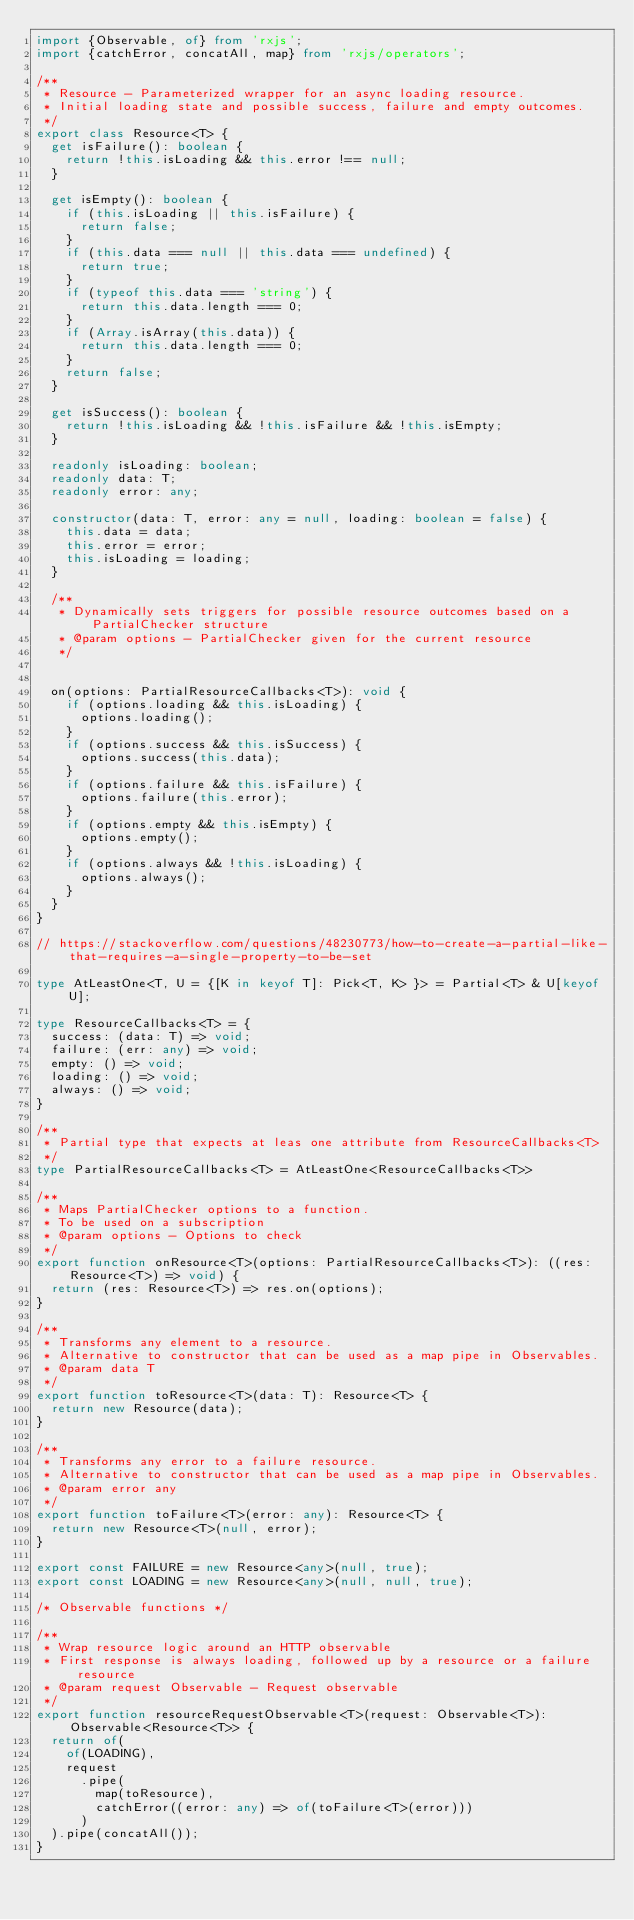Convert code to text. <code><loc_0><loc_0><loc_500><loc_500><_TypeScript_>import {Observable, of} from 'rxjs';
import {catchError, concatAll, map} from 'rxjs/operators';

/**
 * Resource - Parameterized wrapper for an async loading resource.
 * Initial loading state and possible success, failure and empty outcomes.
 */
export class Resource<T> {
  get isFailure(): boolean {
    return !this.isLoading && this.error !== null;
  }

  get isEmpty(): boolean {
    if (this.isLoading || this.isFailure) {
      return false;
    }
    if (this.data === null || this.data === undefined) {
      return true;
    }
    if (typeof this.data === 'string') {
      return this.data.length === 0;
    }
    if (Array.isArray(this.data)) {
      return this.data.length === 0;
    }
    return false;
  }

  get isSuccess(): boolean {
    return !this.isLoading && !this.isFailure && !this.isEmpty;
  }

  readonly isLoading: boolean;
  readonly data: T;
  readonly error: any;

  constructor(data: T, error: any = null, loading: boolean = false) {
    this.data = data;
    this.error = error;
    this.isLoading = loading;
  }

  /**
   * Dynamically sets triggers for possible resource outcomes based on a PartialChecker structure
   * @param options - PartialChecker given for the current resource
   */


  on(options: PartialResourceCallbacks<T>): void {
    if (options.loading && this.isLoading) {
      options.loading();
    }
    if (options.success && this.isSuccess) {
      options.success(this.data);
    }
    if (options.failure && this.isFailure) {
      options.failure(this.error);
    }
    if (options.empty && this.isEmpty) {
      options.empty();
    }
    if (options.always && !this.isLoading) {
      options.always();
    }
  }
}

// https://stackoverflow.com/questions/48230773/how-to-create-a-partial-like-that-requires-a-single-property-to-be-set

type AtLeastOne<T, U = {[K in keyof T]: Pick<T, K> }> = Partial<T> & U[keyof U];

type ResourceCallbacks<T> = {
  success: (data: T) => void;
  failure: (err: any) => void;
  empty: () => void;
  loading: () => void;
  always: () => void;
}

/**
 * Partial type that expects at leas one attribute from ResourceCallbacks<T>
 */
type PartialResourceCallbacks<T> = AtLeastOne<ResourceCallbacks<T>>

/**
 * Maps PartialChecker options to a function.
 * To be used on a subscription
 * @param options - Options to check
 */
export function onResource<T>(options: PartialResourceCallbacks<T>): ((res: Resource<T>) => void) {
  return (res: Resource<T>) => res.on(options);
}

/**
 * Transforms any element to a resource.
 * Alternative to constructor that can be used as a map pipe in Observables.
 * @param data T
 */
export function toResource<T>(data: T): Resource<T> {
  return new Resource(data);
}

/**
 * Transforms any error to a failure resource.
 * Alternative to constructor that can be used as a map pipe in Observables.
 * @param error any
 */
export function toFailure<T>(error: any): Resource<T> {
  return new Resource<T>(null, error);
}

export const FAILURE = new Resource<any>(null, true);
export const LOADING = new Resource<any>(null, null, true);

/* Observable functions */

/**
 * Wrap resource logic around an HTTP observable
 * First response is always loading, followed up by a resource or a failure resource
 * @param request Observable - Request observable
 */
export function resourceRequestObservable<T>(request: Observable<T>): Observable<Resource<T>> {
  return of(
    of(LOADING),
    request
      .pipe(
        map(toResource),
        catchError((error: any) => of(toFailure<T>(error)))
      )
  ).pipe(concatAll());
}
</code> 